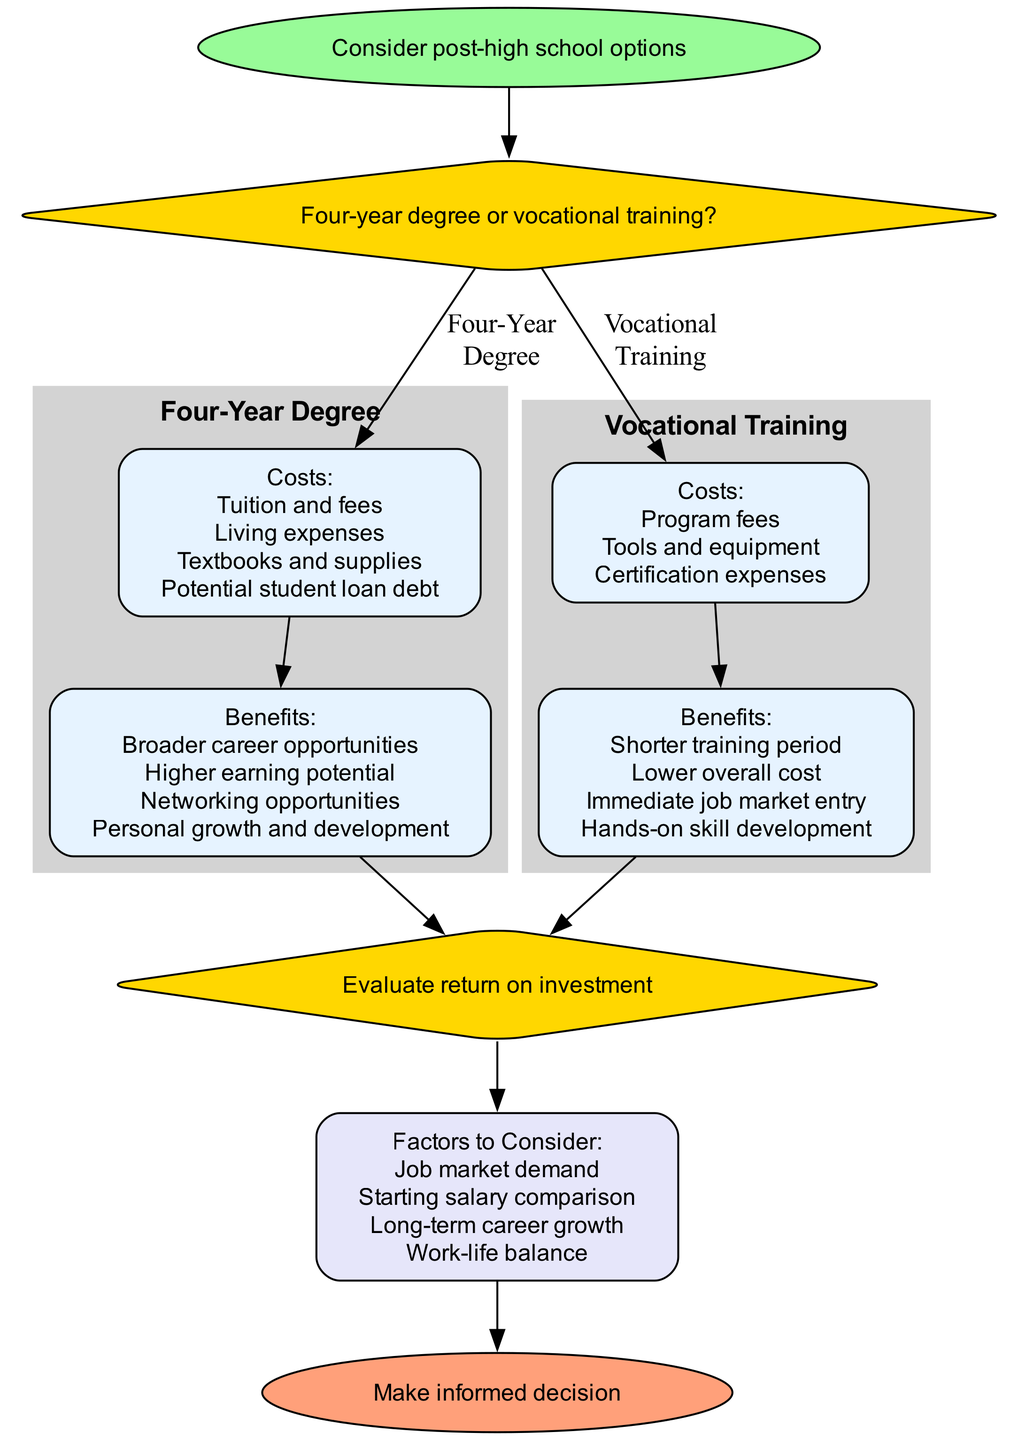What is the first step in the flowchart? The first step in the flowchart is represented by the "start" node, which states "Consider post-high school options." This is the initialization point before any decisions are made.
Answer: Consider post-high school options How many costs are associated with a four-year degree? In the subgraph for "Four-Year Degree," there are four costs listed: Tuition and fees, Living expenses, Textbooks and supplies, and Potential student loan debt. Therefore, the total count of costs is four.
Answer: Four What are the benefits of vocational training? The benefits listed for vocational training are: Shorter training period, Lower overall cost, Immediate job market entry, and Hands-on skill development. These benefits are clearly outlined in the respective subgraph.
Answer: Shorter training period, Lower overall cost, Immediate job market entry, Hands-on skill development Which decision leads to evaluating return on investment? The decision leading to evaluating return on investment is represented by "decision2," following the benefits of both educational paths. After assessing costs and benefits, the flowchart indicates both paths lead to this decision for further evaluation.
Answer: Evaluate return on investment What are the factors that need to be evaluated? The factors to be considered are listed in the "factors" node. They include Job market demand, Starting salary comparison, Long-term career growth, and Work-life balance. All of these elements are essential for making an informed decision after weighing both options.
Answer: Job market demand, Starting salary comparison, Long-term career growth, Work-life balance Which option has a shorter training period? The vocational training option has a shorter training period as explicitly stated in the benefits listed in the relevant subsection of the flowchart. This indicates that one can complete training more quickly compared to obtaining a four-year degree.
Answer: Shorter training period How does the cost of vocational training compare to that of a four-year degree? Vocational training is noted for its lower overall cost in the respective benefits section, whereas the four-year degree entails multiple costs including tuition and fees along with living expenses. Thus, vocational training is comparatively less expensive.
Answer: Lower overall cost What is the end point of the flowchart? The end point of the flowchart is represented by the "end" node, which states "Make informed decision." This indicates that after evaluating all sections of the diagram, the ultimate goal is to reach an informed decision about educational pathways.
Answer: Make informed decision 